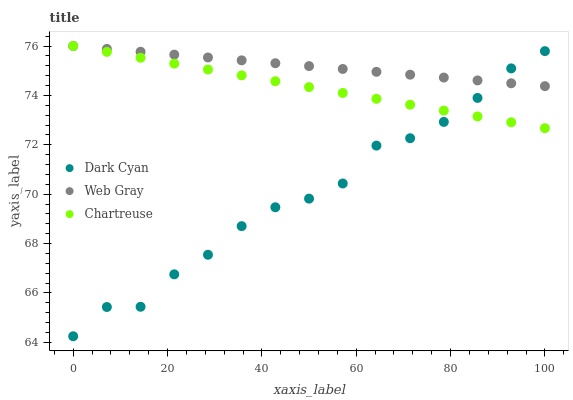Does Dark Cyan have the minimum area under the curve?
Answer yes or no. Yes. Does Web Gray have the maximum area under the curve?
Answer yes or no. Yes. Does Chartreuse have the minimum area under the curve?
Answer yes or no. No. Does Chartreuse have the maximum area under the curve?
Answer yes or no. No. Is Chartreuse the smoothest?
Answer yes or no. Yes. Is Dark Cyan the roughest?
Answer yes or no. Yes. Is Web Gray the smoothest?
Answer yes or no. No. Is Web Gray the roughest?
Answer yes or no. No. Does Dark Cyan have the lowest value?
Answer yes or no. Yes. Does Chartreuse have the lowest value?
Answer yes or no. No. Does Web Gray have the highest value?
Answer yes or no. Yes. Does Web Gray intersect Chartreuse?
Answer yes or no. Yes. Is Web Gray less than Chartreuse?
Answer yes or no. No. Is Web Gray greater than Chartreuse?
Answer yes or no. No. 